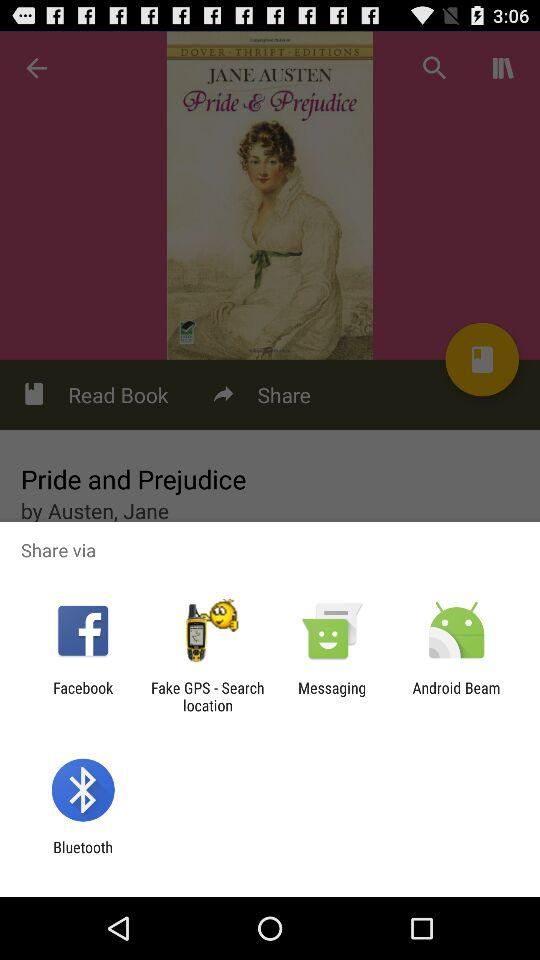Which author wrote the book? The author is Jane Austen. 